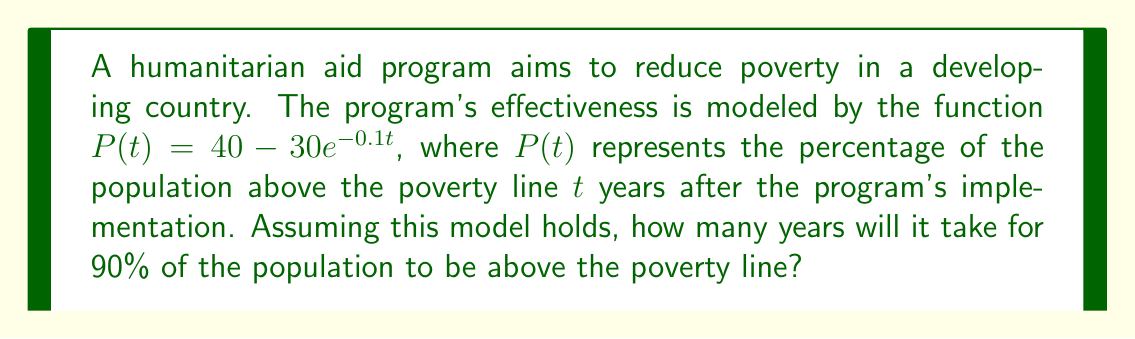Show me your answer to this math problem. To solve this problem, we need to follow these steps:

1) We want to find $t$ when $P(t) = 90$, as this represents 90% of the population above the poverty line.

2) Substitute this into our equation:
   $90 = 40 - 30e^{-0.1t}$

3) Subtract 40 from both sides:
   $50 = -30e^{-0.1t}$

4) Divide both sides by -30:
   $-\frac{5}{3} = e^{-0.1t}$

5) Take the natural logarithm of both sides:
   $\ln(-\frac{5}{3}) = -0.1t$

6) Divide both sides by -0.1:
   $\frac{\ln(-\frac{5}{3})}{-0.1} = t$

7) Simplify:
   $t = 10\ln(\frac{5}{3}) \approx 5.0856$

8) Since we're dealing with years, we need to round up to the nearest whole year.

Therefore, it will take 6 years for 90% of the population to be above the poverty line according to this model.
Answer: 6 years 